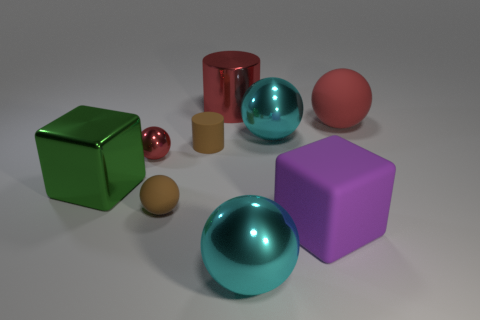Subtract all brown spheres. How many spheres are left? 4 Subtract all small rubber balls. How many balls are left? 4 Subtract all yellow balls. Subtract all yellow cylinders. How many balls are left? 5 Add 1 big purple cubes. How many objects exist? 10 Subtract all cylinders. How many objects are left? 7 Subtract 1 red cylinders. How many objects are left? 8 Subtract all cyan things. Subtract all small metallic balls. How many objects are left? 6 Add 5 shiny things. How many shiny things are left? 10 Add 6 big red rubber things. How many big red rubber things exist? 7 